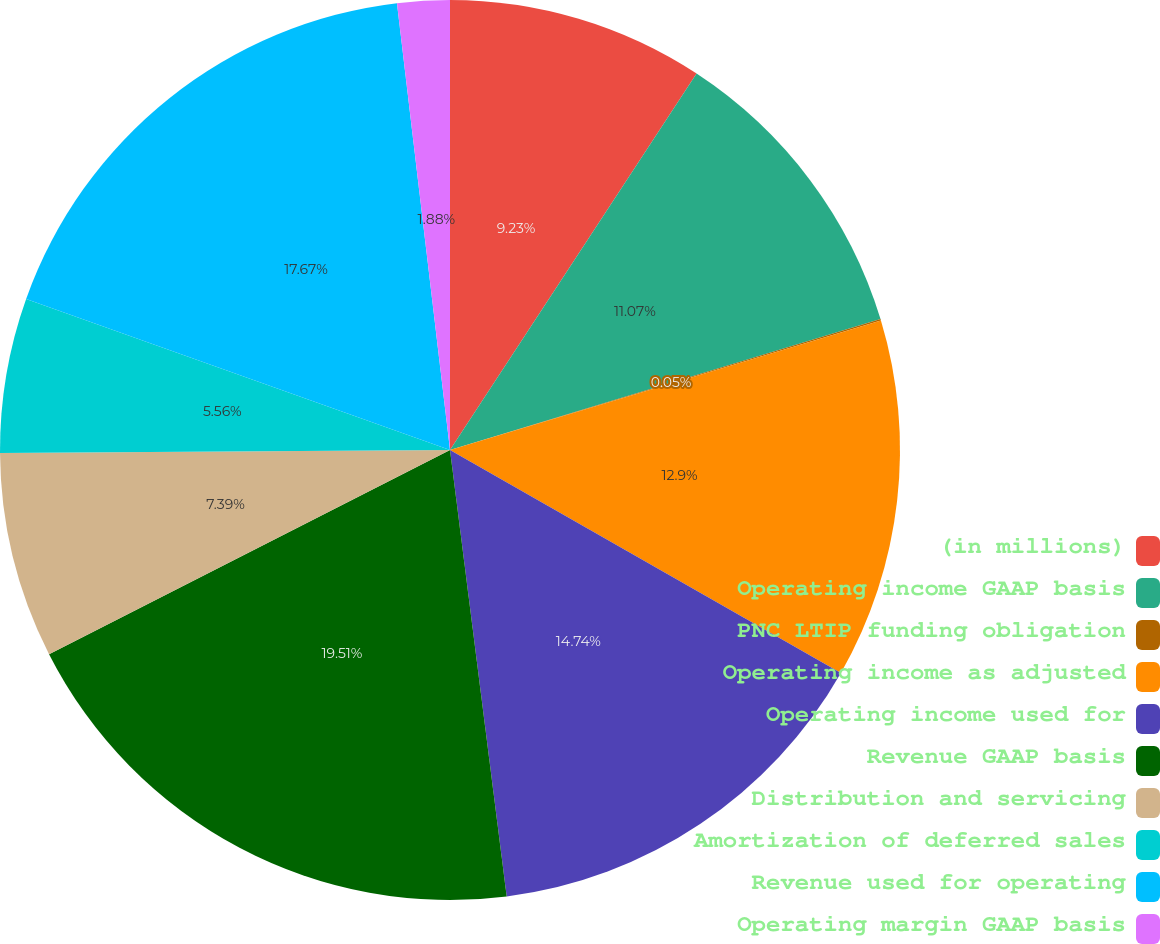Convert chart. <chart><loc_0><loc_0><loc_500><loc_500><pie_chart><fcel>(in millions)<fcel>Operating income GAAP basis<fcel>PNC LTIP funding obligation<fcel>Operating income as adjusted<fcel>Operating income used for<fcel>Revenue GAAP basis<fcel>Distribution and servicing<fcel>Amortization of deferred sales<fcel>Revenue used for operating<fcel>Operating margin GAAP basis<nl><fcel>9.23%<fcel>11.07%<fcel>0.05%<fcel>12.9%<fcel>14.74%<fcel>19.51%<fcel>7.39%<fcel>5.56%<fcel>17.67%<fcel>1.88%<nl></chart> 